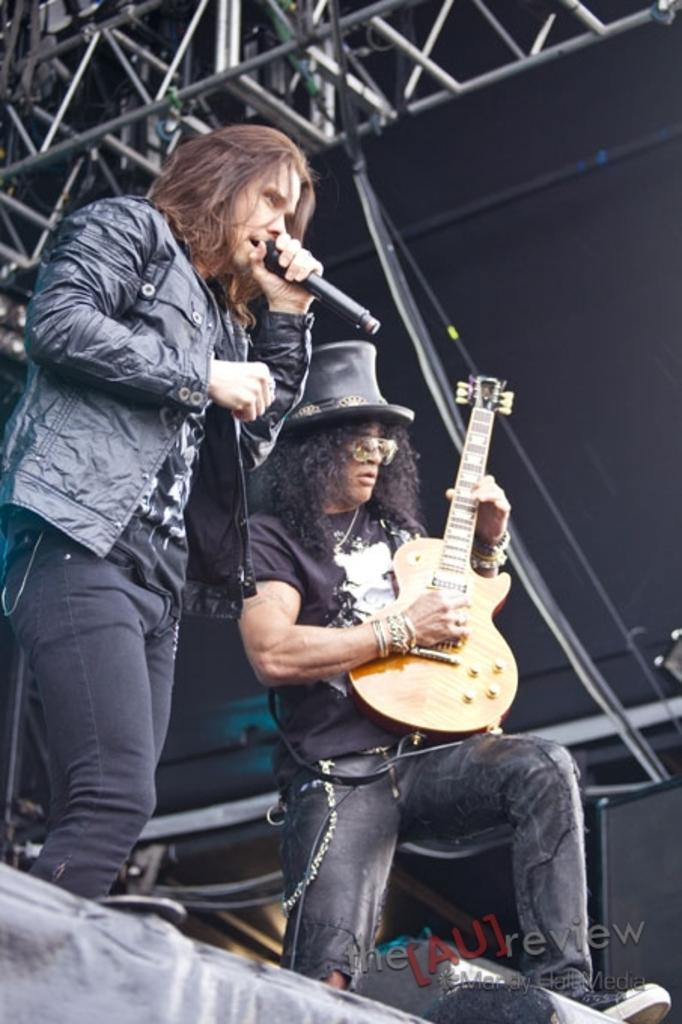How many people are in the image? There are two persons standing in the image. What is one person doing in the image? One person is holding a microphone. What is the person holding the microphone doing? The person holding the microphone is singing. What is the other person doing in the image? The other person is playing a guitar. What type of coil is visible in the image? There is no coil present in the image; it features two people, one holding a microphone and singing, and the other playing a guitar. What kind of trouble is the person holding the microphone experiencing in the image? There is no indication of trouble in the image; the person holding the microphone is singing, and the other person is playing a guitar. 